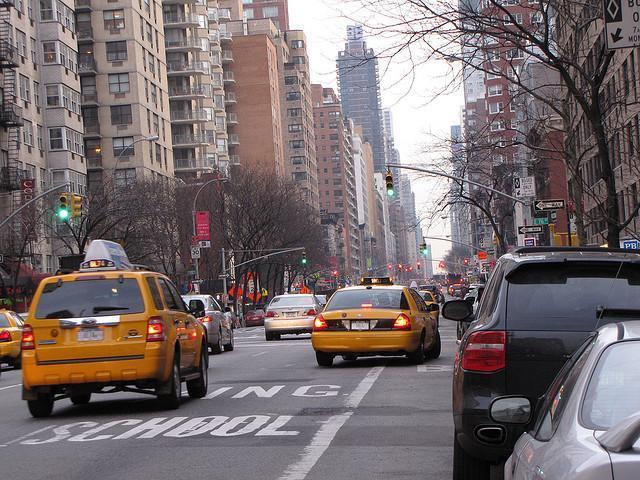How many taxis are there?
Give a very brief answer. 2. How many cars are there?
Give a very brief answer. 5. 